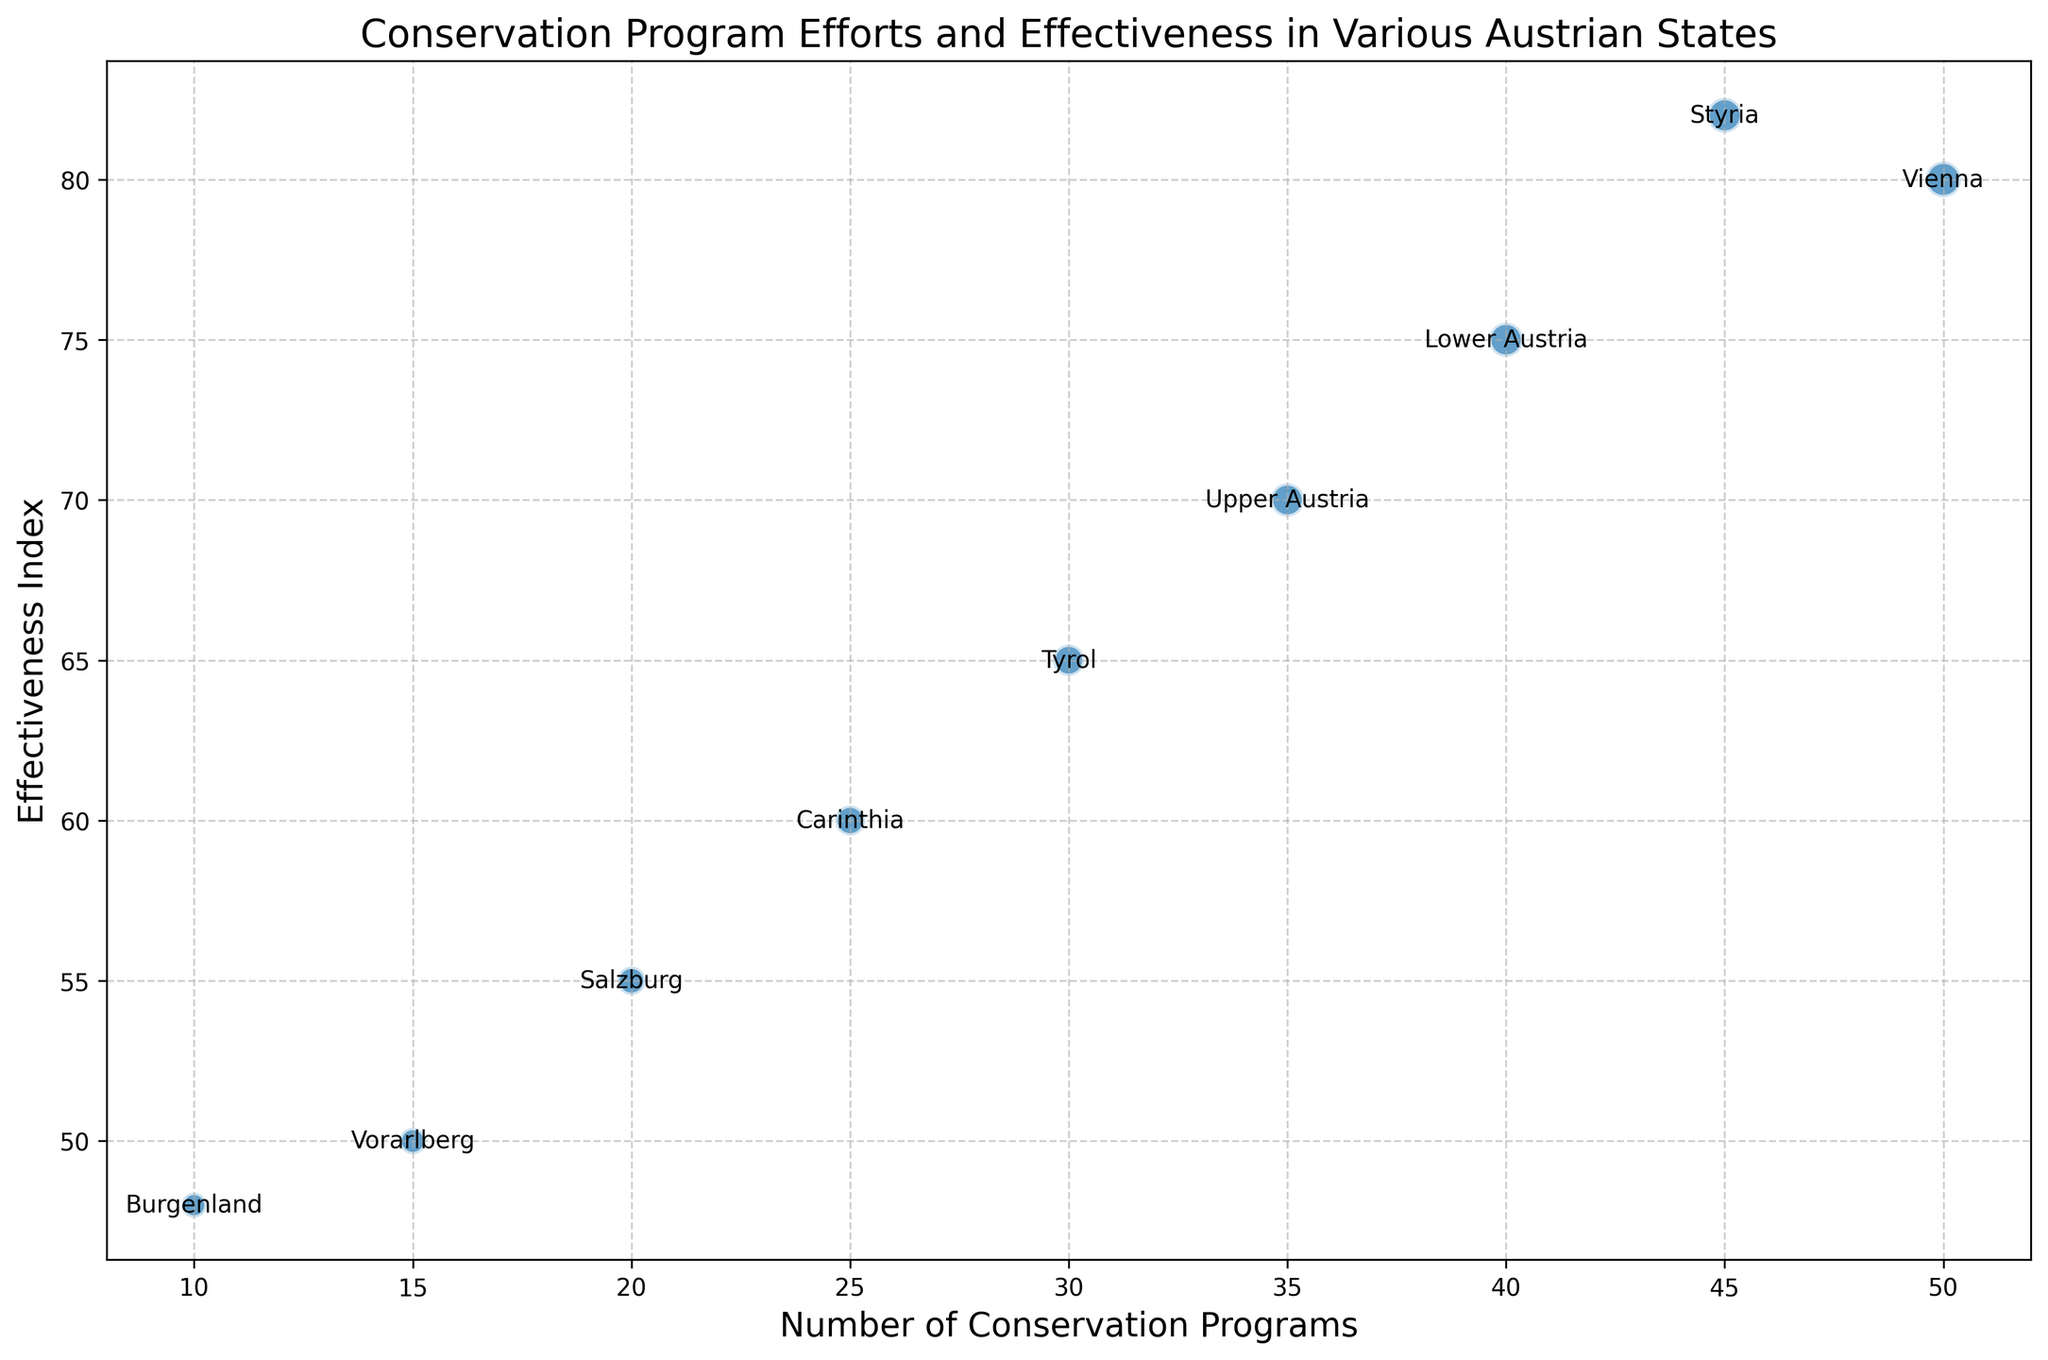Which state has the highest effectiveness index? By looking at the y-axis with the highest value on the chart and reading the corresponding label, we can determine that Styria has the highest effectiveness index of 82.
Answer: Styria Which state has the fewest conservation programs? By looking at the x-axis with the lowest value on the chart and reading the corresponding label, we can see that Burgenland has the fewest conservation programs with 10 programs.
Answer: Burgenland What is the difference between the budgets allocated for Vienna and Vorarlberg? Vienna has a budget of 500,000 and Vorarlberg has a budget of 150,000. The difference is 500,000 - 150,000 = 350,000
Answer: 350,000 Which state has a higher effectiveness index, Salzburg or Tyrol? By looking at the y-axis positions for Salzburg and Tyrol and reading the values, Tyrol has an effectiveness index of 65, and Salzburg has 55. Tyrol has the higher effectiveness index.
Answer: Tyrol How many states have a budget allocated more than 300,000? Identifying the bubbles with sizes indicating more than 300,000 in budget, we find Vienna, Lower Austria, Upper Austria, and Styria, making a total of 4 states.
Answer: 4 What is the average number of conservation programs in Vienna, Lower Austria, and Upper Austria? Vienna has 50, Lower Austria has 40, and Upper Austria has 35 programs. The average is (50 + 40 + 35) / 3 = 125 / 3 = 41.67
Answer: 41.67 Calculate the total budget allocated for the three states with the lowest effectiveness index. The three states with the lowest effectiveness index are Burgenland (120,000), Vorarlberg (150,000), and Salzburg (200,000). The total budget is 120,000 + 150,000 + 200,000 = 470,000.
Answer: 470,000 If Tyrol wants to increase its effectiveness index to match Lower Austria, by how many points does it need to improve? Tyrol's current effectiveness index is 65, and Lower Austria's is 75. The difference is 75 - 65 = 10 points.
Answer: 10 Which state has the smallest bubble size, indicating the lowest budget allocated? The smallest bubble size can be observed for Burgenland with a budget of 120,000.
Answer: Burgenland How does the number of conservation programs in Carinthia compare to that in Salzburg? Carinthia has 25 conservation programs and Salzburg has 20, making Carinthia have 5 more programs than Salzburg.
Answer: Carinthia has more 